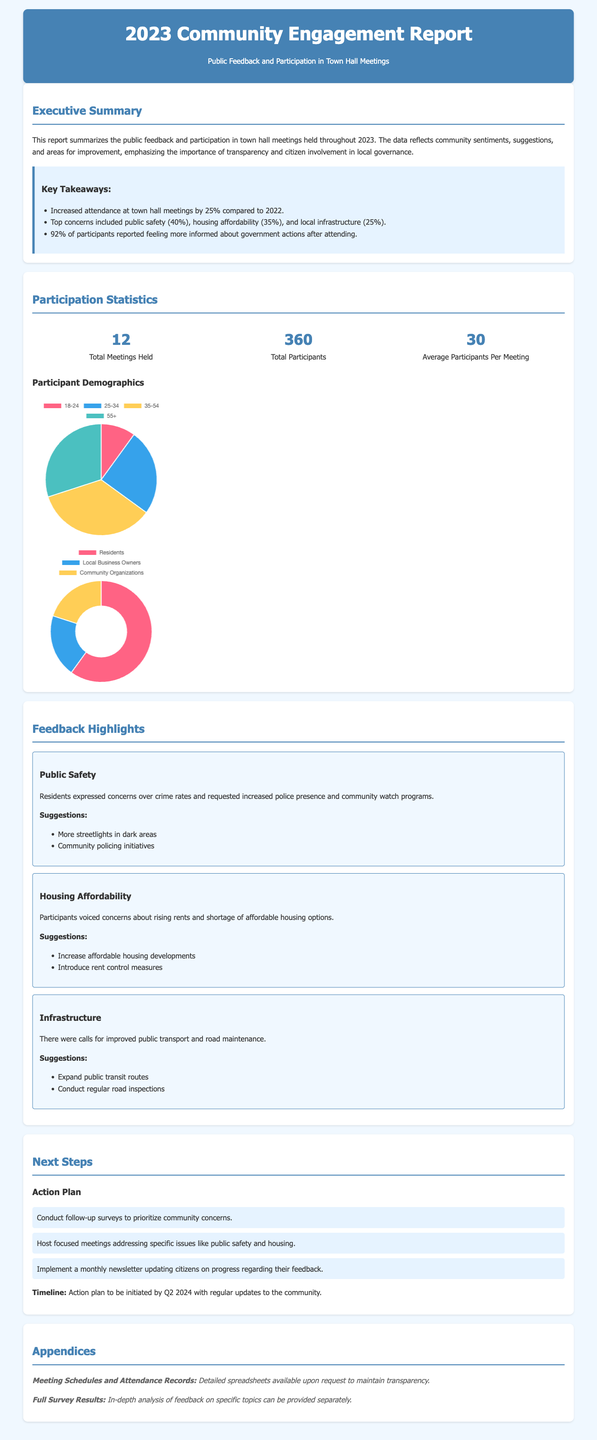What is the total number of town hall meetings held? The document states that a total of 12 meetings were held in 2023.
Answer: 12 What percentage of participants reported feeling more informed? According to the key takeaways, 92% of participants felt more informed about government actions after attending.
Answer: 92% What was the top concern expressed by participants? The document indicates that public safety was the top concern at 40%.
Answer: Public safety What is the average number of participants per meeting? The statistics section provides an average of 30 participants per meeting.
Answer: 30 What are the suggestions for improving public safety? The feedback highlights two key suggestions: more streetlights in dark areas and community policing initiatives.
Answer: More streetlights in dark areas, Community policing initiatives Which demographic made up the majority of participants? The participant backgrounds show that 60% were residents, making them the majority.
Answer: Residents What is the planned timeline for the action plan? The report states that the action plan is to be initiated by Q2 2024.
Answer: Q2 2024 How many total participants attended the town hall meetings? The document mentions a total of 360 participants throughout the year.
Answer: 360 What type of report is this? The document is a community engagement report summarizing public feedback and participation.
Answer: Community engagement report 